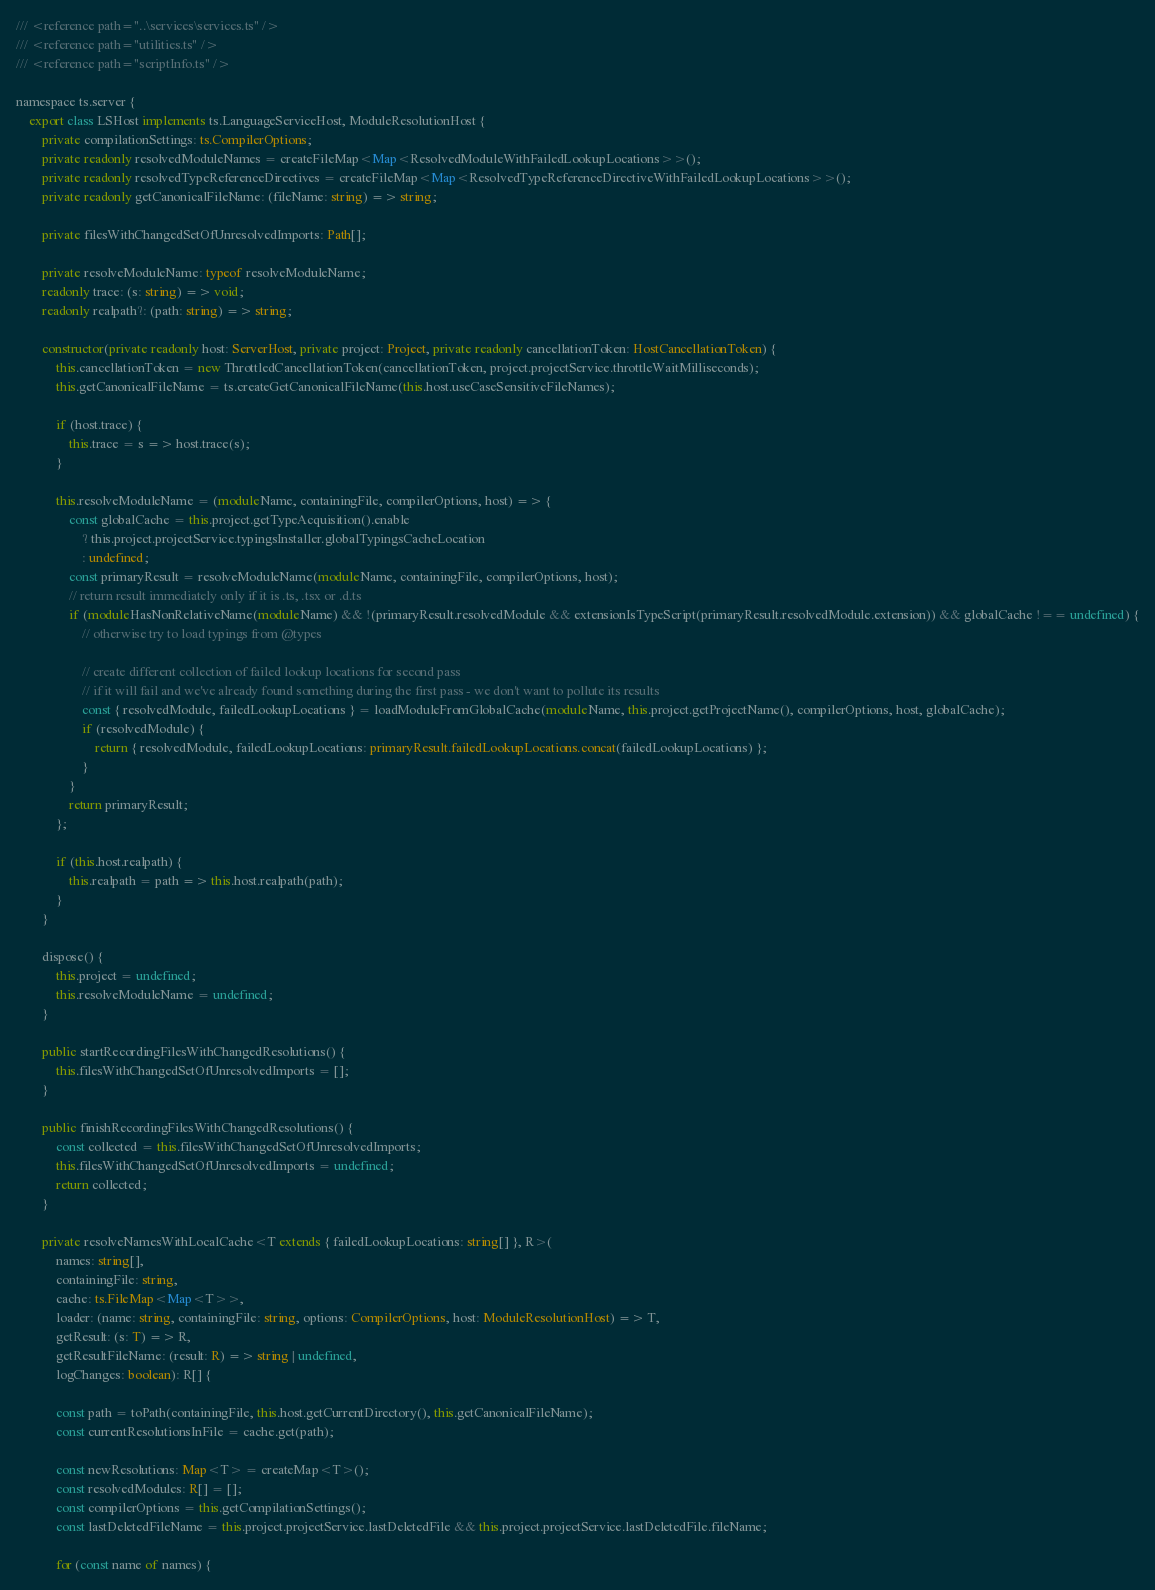Convert code to text. <code><loc_0><loc_0><loc_500><loc_500><_TypeScript_>/// <reference path="..\services\services.ts" />
/// <reference path="utilities.ts" />
/// <reference path="scriptInfo.ts" />

namespace ts.server {
    export class LSHost implements ts.LanguageServiceHost, ModuleResolutionHost {
        private compilationSettings: ts.CompilerOptions;
        private readonly resolvedModuleNames = createFileMap<Map<ResolvedModuleWithFailedLookupLocations>>();
        private readonly resolvedTypeReferenceDirectives = createFileMap<Map<ResolvedTypeReferenceDirectiveWithFailedLookupLocations>>();
        private readonly getCanonicalFileName: (fileName: string) => string;

        private filesWithChangedSetOfUnresolvedImports: Path[];

        private resolveModuleName: typeof resolveModuleName;
        readonly trace: (s: string) => void;
        readonly realpath?: (path: string) => string;

        constructor(private readonly host: ServerHost, private project: Project, private readonly cancellationToken: HostCancellationToken) {
            this.cancellationToken = new ThrottledCancellationToken(cancellationToken, project.projectService.throttleWaitMilliseconds);
            this.getCanonicalFileName = ts.createGetCanonicalFileName(this.host.useCaseSensitiveFileNames);

            if (host.trace) {
                this.trace = s => host.trace(s);
            }

            this.resolveModuleName = (moduleName, containingFile, compilerOptions, host) => {
                const globalCache = this.project.getTypeAcquisition().enable
                    ? this.project.projectService.typingsInstaller.globalTypingsCacheLocation
                    : undefined;
                const primaryResult = resolveModuleName(moduleName, containingFile, compilerOptions, host);
                // return result immediately only if it is .ts, .tsx or .d.ts
                if (moduleHasNonRelativeName(moduleName) && !(primaryResult.resolvedModule && extensionIsTypeScript(primaryResult.resolvedModule.extension)) && globalCache !== undefined) {
                    // otherwise try to load typings from @types

                    // create different collection of failed lookup locations for second pass
                    // if it will fail and we've already found something during the first pass - we don't want to pollute its results
                    const { resolvedModule, failedLookupLocations } = loadModuleFromGlobalCache(moduleName, this.project.getProjectName(), compilerOptions, host, globalCache);
                    if (resolvedModule) {
                        return { resolvedModule, failedLookupLocations: primaryResult.failedLookupLocations.concat(failedLookupLocations) };
                    }
                }
                return primaryResult;
            };

            if (this.host.realpath) {
                this.realpath = path => this.host.realpath(path);
            }
        }

        dispose() {
            this.project = undefined;
            this.resolveModuleName = undefined;
        }

        public startRecordingFilesWithChangedResolutions() {
            this.filesWithChangedSetOfUnresolvedImports = [];
        }

        public finishRecordingFilesWithChangedResolutions() {
            const collected = this.filesWithChangedSetOfUnresolvedImports;
            this.filesWithChangedSetOfUnresolvedImports = undefined;
            return collected;
        }

        private resolveNamesWithLocalCache<T extends { failedLookupLocations: string[] }, R>(
            names: string[],
            containingFile: string,
            cache: ts.FileMap<Map<T>>,
            loader: (name: string, containingFile: string, options: CompilerOptions, host: ModuleResolutionHost) => T,
            getResult: (s: T) => R,
            getResultFileName: (result: R) => string | undefined,
            logChanges: boolean): R[] {

            const path = toPath(containingFile, this.host.getCurrentDirectory(), this.getCanonicalFileName);
            const currentResolutionsInFile = cache.get(path);

            const newResolutions: Map<T> = createMap<T>();
            const resolvedModules: R[] = [];
            const compilerOptions = this.getCompilationSettings();
            const lastDeletedFileName = this.project.projectService.lastDeletedFile && this.project.projectService.lastDeletedFile.fileName;

            for (const name of names) {</code> 